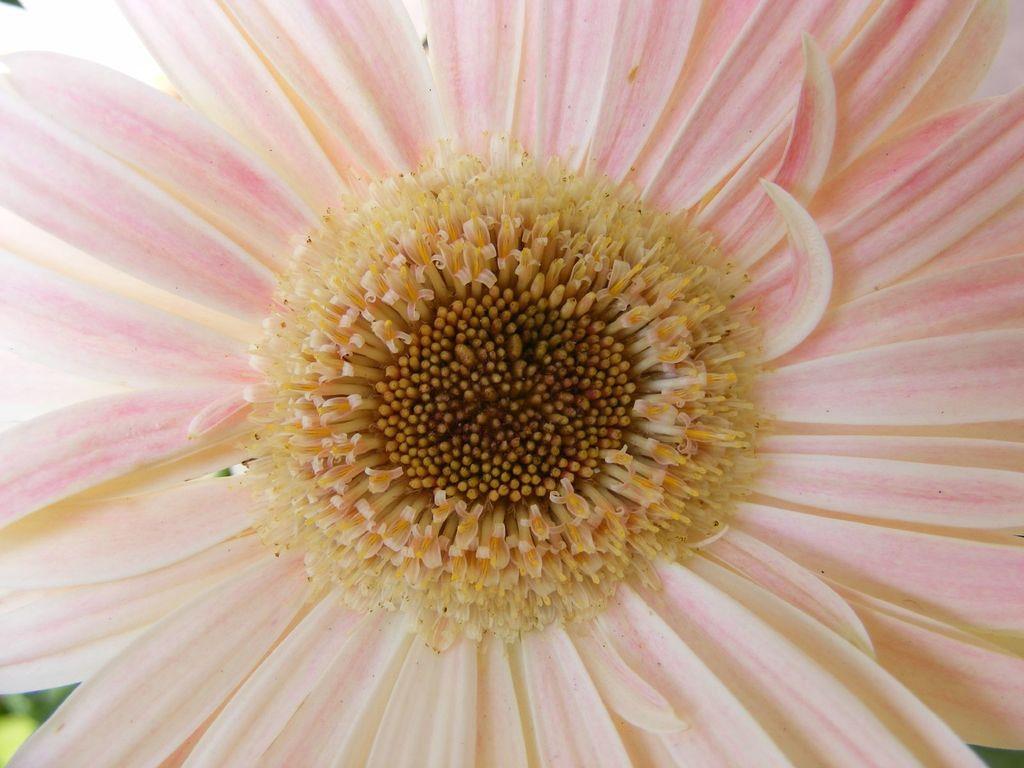In one or two sentences, can you explain what this image depicts? In this image we can see a flower in pink color. 